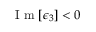Convert formula to latex. <formula><loc_0><loc_0><loc_500><loc_500>I m [ \epsilon _ { 3 } ] < 0</formula> 